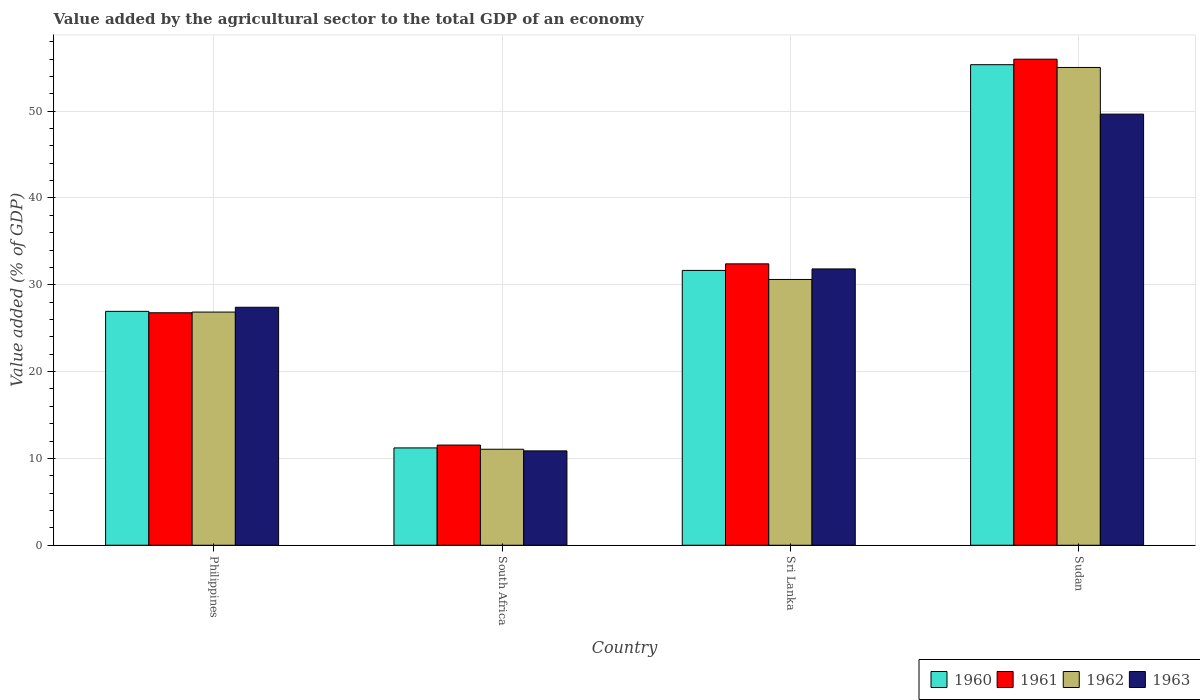How many different coloured bars are there?
Offer a terse response. 4. How many groups of bars are there?
Offer a terse response. 4. Are the number of bars per tick equal to the number of legend labels?
Your answer should be compact. Yes. How many bars are there on the 1st tick from the left?
Your response must be concise. 4. How many bars are there on the 4th tick from the right?
Ensure brevity in your answer.  4. What is the label of the 2nd group of bars from the left?
Your response must be concise. South Africa. In how many cases, is the number of bars for a given country not equal to the number of legend labels?
Keep it short and to the point. 0. What is the value added by the agricultural sector to the total GDP in 1962 in Sudan?
Make the answer very short. 55.03. Across all countries, what is the maximum value added by the agricultural sector to the total GDP in 1961?
Provide a succinct answer. 55.99. Across all countries, what is the minimum value added by the agricultural sector to the total GDP in 1961?
Offer a very short reply. 11.54. In which country was the value added by the agricultural sector to the total GDP in 1960 maximum?
Your response must be concise. Sudan. In which country was the value added by the agricultural sector to the total GDP in 1960 minimum?
Your answer should be compact. South Africa. What is the total value added by the agricultural sector to the total GDP in 1962 in the graph?
Your response must be concise. 123.56. What is the difference between the value added by the agricultural sector to the total GDP in 1963 in Sri Lanka and that in Sudan?
Your answer should be very brief. -17.83. What is the difference between the value added by the agricultural sector to the total GDP in 1963 in Sudan and the value added by the agricultural sector to the total GDP in 1960 in Sri Lanka?
Make the answer very short. 18. What is the average value added by the agricultural sector to the total GDP in 1961 per country?
Your answer should be compact. 31.68. What is the difference between the value added by the agricultural sector to the total GDP of/in 1960 and value added by the agricultural sector to the total GDP of/in 1963 in Sri Lanka?
Give a very brief answer. -0.17. What is the ratio of the value added by the agricultural sector to the total GDP in 1962 in Philippines to that in Sri Lanka?
Offer a very short reply. 0.88. Is the difference between the value added by the agricultural sector to the total GDP in 1960 in South Africa and Sudan greater than the difference between the value added by the agricultural sector to the total GDP in 1963 in South Africa and Sudan?
Keep it short and to the point. No. What is the difference between the highest and the second highest value added by the agricultural sector to the total GDP in 1961?
Your answer should be very brief. 5.63. What is the difference between the highest and the lowest value added by the agricultural sector to the total GDP in 1963?
Provide a succinct answer. 38.79. Is the sum of the value added by the agricultural sector to the total GDP in 1962 in Philippines and Sudan greater than the maximum value added by the agricultural sector to the total GDP in 1963 across all countries?
Ensure brevity in your answer.  Yes. What does the 2nd bar from the right in South Africa represents?
Give a very brief answer. 1962. Are all the bars in the graph horizontal?
Ensure brevity in your answer.  No. Are the values on the major ticks of Y-axis written in scientific E-notation?
Ensure brevity in your answer.  No. Does the graph contain grids?
Make the answer very short. Yes. Where does the legend appear in the graph?
Provide a short and direct response. Bottom right. What is the title of the graph?
Keep it short and to the point. Value added by the agricultural sector to the total GDP of an economy. Does "1983" appear as one of the legend labels in the graph?
Offer a very short reply. No. What is the label or title of the X-axis?
Your answer should be compact. Country. What is the label or title of the Y-axis?
Provide a succinct answer. Value added (% of GDP). What is the Value added (% of GDP) in 1960 in Philippines?
Offer a terse response. 26.94. What is the Value added (% of GDP) of 1961 in Philippines?
Provide a succinct answer. 26.78. What is the Value added (% of GDP) of 1962 in Philippines?
Your answer should be very brief. 26.86. What is the Value added (% of GDP) in 1963 in Philippines?
Provide a succinct answer. 27.41. What is the Value added (% of GDP) in 1960 in South Africa?
Provide a short and direct response. 11.21. What is the Value added (% of GDP) of 1961 in South Africa?
Provide a succinct answer. 11.54. What is the Value added (% of GDP) in 1962 in South Africa?
Keep it short and to the point. 11.06. What is the Value added (% of GDP) of 1963 in South Africa?
Offer a terse response. 10.87. What is the Value added (% of GDP) in 1960 in Sri Lanka?
Your answer should be very brief. 31.66. What is the Value added (% of GDP) in 1961 in Sri Lanka?
Give a very brief answer. 32.41. What is the Value added (% of GDP) of 1962 in Sri Lanka?
Ensure brevity in your answer.  30.61. What is the Value added (% of GDP) in 1963 in Sri Lanka?
Offer a very short reply. 31.83. What is the Value added (% of GDP) in 1960 in Sudan?
Provide a succinct answer. 55.35. What is the Value added (% of GDP) of 1961 in Sudan?
Ensure brevity in your answer.  55.99. What is the Value added (% of GDP) in 1962 in Sudan?
Offer a very short reply. 55.03. What is the Value added (% of GDP) of 1963 in Sudan?
Your response must be concise. 49.66. Across all countries, what is the maximum Value added (% of GDP) in 1960?
Give a very brief answer. 55.35. Across all countries, what is the maximum Value added (% of GDP) of 1961?
Keep it short and to the point. 55.99. Across all countries, what is the maximum Value added (% of GDP) of 1962?
Your answer should be compact. 55.03. Across all countries, what is the maximum Value added (% of GDP) of 1963?
Provide a succinct answer. 49.66. Across all countries, what is the minimum Value added (% of GDP) in 1960?
Provide a succinct answer. 11.21. Across all countries, what is the minimum Value added (% of GDP) in 1961?
Your answer should be compact. 11.54. Across all countries, what is the minimum Value added (% of GDP) of 1962?
Offer a very short reply. 11.06. Across all countries, what is the minimum Value added (% of GDP) in 1963?
Your answer should be compact. 10.87. What is the total Value added (% of GDP) in 1960 in the graph?
Provide a short and direct response. 125.16. What is the total Value added (% of GDP) in 1961 in the graph?
Keep it short and to the point. 126.71. What is the total Value added (% of GDP) in 1962 in the graph?
Give a very brief answer. 123.56. What is the total Value added (% of GDP) of 1963 in the graph?
Keep it short and to the point. 119.77. What is the difference between the Value added (% of GDP) of 1960 in Philippines and that in South Africa?
Ensure brevity in your answer.  15.73. What is the difference between the Value added (% of GDP) in 1961 in Philippines and that in South Africa?
Provide a short and direct response. 15.24. What is the difference between the Value added (% of GDP) of 1962 in Philippines and that in South Africa?
Provide a short and direct response. 15.8. What is the difference between the Value added (% of GDP) in 1963 in Philippines and that in South Africa?
Your answer should be very brief. 16.54. What is the difference between the Value added (% of GDP) in 1960 in Philippines and that in Sri Lanka?
Offer a terse response. -4.72. What is the difference between the Value added (% of GDP) in 1961 in Philippines and that in Sri Lanka?
Your answer should be compact. -5.63. What is the difference between the Value added (% of GDP) in 1962 in Philippines and that in Sri Lanka?
Your response must be concise. -3.76. What is the difference between the Value added (% of GDP) of 1963 in Philippines and that in Sri Lanka?
Make the answer very short. -4.41. What is the difference between the Value added (% of GDP) of 1960 in Philippines and that in Sudan?
Your response must be concise. -28.41. What is the difference between the Value added (% of GDP) of 1961 in Philippines and that in Sudan?
Your answer should be compact. -29.21. What is the difference between the Value added (% of GDP) of 1962 in Philippines and that in Sudan?
Make the answer very short. -28.18. What is the difference between the Value added (% of GDP) in 1963 in Philippines and that in Sudan?
Give a very brief answer. -22.25. What is the difference between the Value added (% of GDP) of 1960 in South Africa and that in Sri Lanka?
Offer a very short reply. -20.45. What is the difference between the Value added (% of GDP) of 1961 in South Africa and that in Sri Lanka?
Ensure brevity in your answer.  -20.87. What is the difference between the Value added (% of GDP) of 1962 in South Africa and that in Sri Lanka?
Provide a short and direct response. -19.56. What is the difference between the Value added (% of GDP) of 1963 in South Africa and that in Sri Lanka?
Provide a short and direct response. -20.96. What is the difference between the Value added (% of GDP) in 1960 in South Africa and that in Sudan?
Make the answer very short. -44.14. What is the difference between the Value added (% of GDP) in 1961 in South Africa and that in Sudan?
Offer a very short reply. -44.45. What is the difference between the Value added (% of GDP) in 1962 in South Africa and that in Sudan?
Offer a very short reply. -43.98. What is the difference between the Value added (% of GDP) of 1963 in South Africa and that in Sudan?
Offer a terse response. -38.79. What is the difference between the Value added (% of GDP) of 1960 in Sri Lanka and that in Sudan?
Ensure brevity in your answer.  -23.7. What is the difference between the Value added (% of GDP) of 1961 in Sri Lanka and that in Sudan?
Your response must be concise. -23.58. What is the difference between the Value added (% of GDP) of 1962 in Sri Lanka and that in Sudan?
Your answer should be very brief. -24.42. What is the difference between the Value added (% of GDP) in 1963 in Sri Lanka and that in Sudan?
Make the answer very short. -17.83. What is the difference between the Value added (% of GDP) of 1960 in Philippines and the Value added (% of GDP) of 1961 in South Africa?
Offer a terse response. 15.4. What is the difference between the Value added (% of GDP) in 1960 in Philippines and the Value added (% of GDP) in 1962 in South Africa?
Your response must be concise. 15.88. What is the difference between the Value added (% of GDP) of 1960 in Philippines and the Value added (% of GDP) of 1963 in South Africa?
Provide a short and direct response. 16.07. What is the difference between the Value added (% of GDP) in 1961 in Philippines and the Value added (% of GDP) in 1962 in South Africa?
Ensure brevity in your answer.  15.72. What is the difference between the Value added (% of GDP) in 1961 in Philippines and the Value added (% of GDP) in 1963 in South Africa?
Offer a terse response. 15.91. What is the difference between the Value added (% of GDP) in 1962 in Philippines and the Value added (% of GDP) in 1963 in South Africa?
Offer a terse response. 15.99. What is the difference between the Value added (% of GDP) in 1960 in Philippines and the Value added (% of GDP) in 1961 in Sri Lanka?
Provide a succinct answer. -5.47. What is the difference between the Value added (% of GDP) of 1960 in Philippines and the Value added (% of GDP) of 1962 in Sri Lanka?
Provide a succinct answer. -3.67. What is the difference between the Value added (% of GDP) in 1960 in Philippines and the Value added (% of GDP) in 1963 in Sri Lanka?
Ensure brevity in your answer.  -4.89. What is the difference between the Value added (% of GDP) in 1961 in Philippines and the Value added (% of GDP) in 1962 in Sri Lanka?
Your answer should be very brief. -3.84. What is the difference between the Value added (% of GDP) in 1961 in Philippines and the Value added (% of GDP) in 1963 in Sri Lanka?
Your response must be concise. -5.05. What is the difference between the Value added (% of GDP) in 1962 in Philippines and the Value added (% of GDP) in 1963 in Sri Lanka?
Provide a succinct answer. -4.97. What is the difference between the Value added (% of GDP) of 1960 in Philippines and the Value added (% of GDP) of 1961 in Sudan?
Provide a short and direct response. -29.05. What is the difference between the Value added (% of GDP) of 1960 in Philippines and the Value added (% of GDP) of 1962 in Sudan?
Make the answer very short. -28.09. What is the difference between the Value added (% of GDP) in 1960 in Philippines and the Value added (% of GDP) in 1963 in Sudan?
Provide a short and direct response. -22.72. What is the difference between the Value added (% of GDP) in 1961 in Philippines and the Value added (% of GDP) in 1962 in Sudan?
Ensure brevity in your answer.  -28.26. What is the difference between the Value added (% of GDP) in 1961 in Philippines and the Value added (% of GDP) in 1963 in Sudan?
Offer a terse response. -22.88. What is the difference between the Value added (% of GDP) of 1962 in Philippines and the Value added (% of GDP) of 1963 in Sudan?
Offer a terse response. -22.8. What is the difference between the Value added (% of GDP) in 1960 in South Africa and the Value added (% of GDP) in 1961 in Sri Lanka?
Offer a terse response. -21.2. What is the difference between the Value added (% of GDP) in 1960 in South Africa and the Value added (% of GDP) in 1962 in Sri Lanka?
Your response must be concise. -19.4. What is the difference between the Value added (% of GDP) of 1960 in South Africa and the Value added (% of GDP) of 1963 in Sri Lanka?
Your answer should be very brief. -20.62. What is the difference between the Value added (% of GDP) of 1961 in South Africa and the Value added (% of GDP) of 1962 in Sri Lanka?
Your answer should be compact. -19.08. What is the difference between the Value added (% of GDP) of 1961 in South Africa and the Value added (% of GDP) of 1963 in Sri Lanka?
Provide a succinct answer. -20.29. What is the difference between the Value added (% of GDP) of 1962 in South Africa and the Value added (% of GDP) of 1963 in Sri Lanka?
Keep it short and to the point. -20.77. What is the difference between the Value added (% of GDP) of 1960 in South Africa and the Value added (% of GDP) of 1961 in Sudan?
Offer a very short reply. -44.78. What is the difference between the Value added (% of GDP) in 1960 in South Africa and the Value added (% of GDP) in 1962 in Sudan?
Keep it short and to the point. -43.82. What is the difference between the Value added (% of GDP) in 1960 in South Africa and the Value added (% of GDP) in 1963 in Sudan?
Your response must be concise. -38.45. What is the difference between the Value added (% of GDP) in 1961 in South Africa and the Value added (% of GDP) in 1962 in Sudan?
Your answer should be compact. -43.5. What is the difference between the Value added (% of GDP) of 1961 in South Africa and the Value added (% of GDP) of 1963 in Sudan?
Your answer should be compact. -38.12. What is the difference between the Value added (% of GDP) in 1962 in South Africa and the Value added (% of GDP) in 1963 in Sudan?
Provide a short and direct response. -38.6. What is the difference between the Value added (% of GDP) in 1960 in Sri Lanka and the Value added (% of GDP) in 1961 in Sudan?
Provide a succinct answer. -24.33. What is the difference between the Value added (% of GDP) of 1960 in Sri Lanka and the Value added (% of GDP) of 1962 in Sudan?
Give a very brief answer. -23.38. What is the difference between the Value added (% of GDP) in 1960 in Sri Lanka and the Value added (% of GDP) in 1963 in Sudan?
Offer a terse response. -18. What is the difference between the Value added (% of GDP) in 1961 in Sri Lanka and the Value added (% of GDP) in 1962 in Sudan?
Keep it short and to the point. -22.62. What is the difference between the Value added (% of GDP) in 1961 in Sri Lanka and the Value added (% of GDP) in 1963 in Sudan?
Make the answer very short. -17.25. What is the difference between the Value added (% of GDP) in 1962 in Sri Lanka and the Value added (% of GDP) in 1963 in Sudan?
Make the answer very short. -19.04. What is the average Value added (% of GDP) in 1960 per country?
Provide a succinct answer. 31.29. What is the average Value added (% of GDP) in 1961 per country?
Ensure brevity in your answer.  31.68. What is the average Value added (% of GDP) in 1962 per country?
Provide a short and direct response. 30.89. What is the average Value added (% of GDP) of 1963 per country?
Keep it short and to the point. 29.94. What is the difference between the Value added (% of GDP) in 1960 and Value added (% of GDP) in 1961 in Philippines?
Ensure brevity in your answer.  0.16. What is the difference between the Value added (% of GDP) of 1960 and Value added (% of GDP) of 1962 in Philippines?
Provide a short and direct response. 0.08. What is the difference between the Value added (% of GDP) in 1960 and Value added (% of GDP) in 1963 in Philippines?
Give a very brief answer. -0.47. What is the difference between the Value added (% of GDP) in 1961 and Value added (% of GDP) in 1962 in Philippines?
Your response must be concise. -0.08. What is the difference between the Value added (% of GDP) of 1961 and Value added (% of GDP) of 1963 in Philippines?
Offer a very short reply. -0.64. What is the difference between the Value added (% of GDP) in 1962 and Value added (% of GDP) in 1963 in Philippines?
Give a very brief answer. -0.55. What is the difference between the Value added (% of GDP) of 1960 and Value added (% of GDP) of 1961 in South Africa?
Give a very brief answer. -0.33. What is the difference between the Value added (% of GDP) in 1960 and Value added (% of GDP) in 1962 in South Africa?
Provide a succinct answer. 0.15. What is the difference between the Value added (% of GDP) of 1960 and Value added (% of GDP) of 1963 in South Africa?
Offer a very short reply. 0.34. What is the difference between the Value added (% of GDP) of 1961 and Value added (% of GDP) of 1962 in South Africa?
Give a very brief answer. 0.48. What is the difference between the Value added (% of GDP) of 1961 and Value added (% of GDP) of 1963 in South Africa?
Your response must be concise. 0.67. What is the difference between the Value added (% of GDP) of 1962 and Value added (% of GDP) of 1963 in South Africa?
Offer a terse response. 0.19. What is the difference between the Value added (% of GDP) of 1960 and Value added (% of GDP) of 1961 in Sri Lanka?
Provide a succinct answer. -0.76. What is the difference between the Value added (% of GDP) in 1960 and Value added (% of GDP) in 1962 in Sri Lanka?
Offer a very short reply. 1.04. What is the difference between the Value added (% of GDP) in 1960 and Value added (% of GDP) in 1963 in Sri Lanka?
Your response must be concise. -0.17. What is the difference between the Value added (% of GDP) in 1961 and Value added (% of GDP) in 1962 in Sri Lanka?
Give a very brief answer. 1.8. What is the difference between the Value added (% of GDP) in 1961 and Value added (% of GDP) in 1963 in Sri Lanka?
Offer a very short reply. 0.59. What is the difference between the Value added (% of GDP) of 1962 and Value added (% of GDP) of 1963 in Sri Lanka?
Provide a short and direct response. -1.21. What is the difference between the Value added (% of GDP) in 1960 and Value added (% of GDP) in 1961 in Sudan?
Provide a short and direct response. -0.64. What is the difference between the Value added (% of GDP) of 1960 and Value added (% of GDP) of 1962 in Sudan?
Offer a very short reply. 0.32. What is the difference between the Value added (% of GDP) of 1960 and Value added (% of GDP) of 1963 in Sudan?
Offer a terse response. 5.69. What is the difference between the Value added (% of GDP) in 1961 and Value added (% of GDP) in 1962 in Sudan?
Provide a succinct answer. 0.95. What is the difference between the Value added (% of GDP) of 1961 and Value added (% of GDP) of 1963 in Sudan?
Make the answer very short. 6.33. What is the difference between the Value added (% of GDP) in 1962 and Value added (% of GDP) in 1963 in Sudan?
Your answer should be very brief. 5.37. What is the ratio of the Value added (% of GDP) of 1960 in Philippines to that in South Africa?
Keep it short and to the point. 2.4. What is the ratio of the Value added (% of GDP) of 1961 in Philippines to that in South Africa?
Provide a short and direct response. 2.32. What is the ratio of the Value added (% of GDP) of 1962 in Philippines to that in South Africa?
Provide a succinct answer. 2.43. What is the ratio of the Value added (% of GDP) of 1963 in Philippines to that in South Africa?
Ensure brevity in your answer.  2.52. What is the ratio of the Value added (% of GDP) of 1960 in Philippines to that in Sri Lanka?
Provide a succinct answer. 0.85. What is the ratio of the Value added (% of GDP) of 1961 in Philippines to that in Sri Lanka?
Your answer should be compact. 0.83. What is the ratio of the Value added (% of GDP) of 1962 in Philippines to that in Sri Lanka?
Offer a very short reply. 0.88. What is the ratio of the Value added (% of GDP) in 1963 in Philippines to that in Sri Lanka?
Offer a very short reply. 0.86. What is the ratio of the Value added (% of GDP) of 1960 in Philippines to that in Sudan?
Ensure brevity in your answer.  0.49. What is the ratio of the Value added (% of GDP) of 1961 in Philippines to that in Sudan?
Offer a very short reply. 0.48. What is the ratio of the Value added (% of GDP) in 1962 in Philippines to that in Sudan?
Your response must be concise. 0.49. What is the ratio of the Value added (% of GDP) of 1963 in Philippines to that in Sudan?
Offer a very short reply. 0.55. What is the ratio of the Value added (% of GDP) of 1960 in South Africa to that in Sri Lanka?
Provide a short and direct response. 0.35. What is the ratio of the Value added (% of GDP) in 1961 in South Africa to that in Sri Lanka?
Your answer should be very brief. 0.36. What is the ratio of the Value added (% of GDP) in 1962 in South Africa to that in Sri Lanka?
Keep it short and to the point. 0.36. What is the ratio of the Value added (% of GDP) of 1963 in South Africa to that in Sri Lanka?
Ensure brevity in your answer.  0.34. What is the ratio of the Value added (% of GDP) in 1960 in South Africa to that in Sudan?
Provide a short and direct response. 0.2. What is the ratio of the Value added (% of GDP) in 1961 in South Africa to that in Sudan?
Your answer should be compact. 0.21. What is the ratio of the Value added (% of GDP) of 1962 in South Africa to that in Sudan?
Give a very brief answer. 0.2. What is the ratio of the Value added (% of GDP) of 1963 in South Africa to that in Sudan?
Your response must be concise. 0.22. What is the ratio of the Value added (% of GDP) in 1960 in Sri Lanka to that in Sudan?
Provide a short and direct response. 0.57. What is the ratio of the Value added (% of GDP) of 1961 in Sri Lanka to that in Sudan?
Your answer should be compact. 0.58. What is the ratio of the Value added (% of GDP) of 1962 in Sri Lanka to that in Sudan?
Your response must be concise. 0.56. What is the ratio of the Value added (% of GDP) of 1963 in Sri Lanka to that in Sudan?
Ensure brevity in your answer.  0.64. What is the difference between the highest and the second highest Value added (% of GDP) in 1960?
Provide a short and direct response. 23.7. What is the difference between the highest and the second highest Value added (% of GDP) of 1961?
Your response must be concise. 23.58. What is the difference between the highest and the second highest Value added (% of GDP) of 1962?
Offer a very short reply. 24.42. What is the difference between the highest and the second highest Value added (% of GDP) of 1963?
Ensure brevity in your answer.  17.83. What is the difference between the highest and the lowest Value added (% of GDP) of 1960?
Offer a terse response. 44.14. What is the difference between the highest and the lowest Value added (% of GDP) in 1961?
Provide a succinct answer. 44.45. What is the difference between the highest and the lowest Value added (% of GDP) in 1962?
Offer a terse response. 43.98. What is the difference between the highest and the lowest Value added (% of GDP) in 1963?
Give a very brief answer. 38.79. 